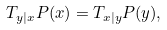<formula> <loc_0><loc_0><loc_500><loc_500>T _ { y | x } P ( x ) = T _ { x | y } P ( y ) ,</formula> 